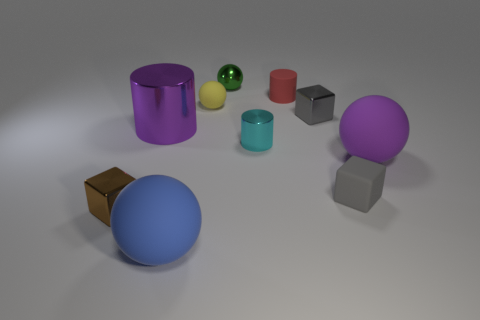How many gray cubes must be subtracted to get 1 gray cubes? 1 Subtract 1 balls. How many balls are left? 3 Subtract all blocks. How many objects are left? 7 Subtract 1 purple balls. How many objects are left? 9 Subtract all metal cubes. Subtract all red spheres. How many objects are left? 8 Add 5 small rubber things. How many small rubber things are left? 8 Add 6 small blue shiny things. How many small blue shiny things exist? 6 